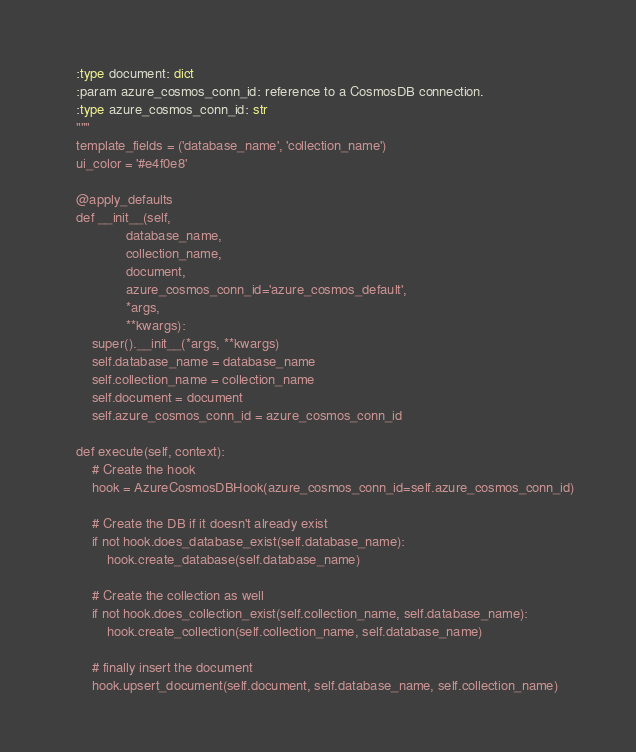Convert code to text. <code><loc_0><loc_0><loc_500><loc_500><_Python_>    :type document: dict
    :param azure_cosmos_conn_id: reference to a CosmosDB connection.
    :type azure_cosmos_conn_id: str
    """
    template_fields = ('database_name', 'collection_name')
    ui_color = '#e4f0e8'

    @apply_defaults
    def __init__(self,
                 database_name,
                 collection_name,
                 document,
                 azure_cosmos_conn_id='azure_cosmos_default',
                 *args,
                 **kwargs):
        super().__init__(*args, **kwargs)
        self.database_name = database_name
        self.collection_name = collection_name
        self.document = document
        self.azure_cosmos_conn_id = azure_cosmos_conn_id

    def execute(self, context):
        # Create the hook
        hook = AzureCosmosDBHook(azure_cosmos_conn_id=self.azure_cosmos_conn_id)

        # Create the DB if it doesn't already exist
        if not hook.does_database_exist(self.database_name):
            hook.create_database(self.database_name)

        # Create the collection as well
        if not hook.does_collection_exist(self.collection_name, self.database_name):
            hook.create_collection(self.collection_name, self.database_name)

        # finally insert the document
        hook.upsert_document(self.document, self.database_name, self.collection_name)
</code> 